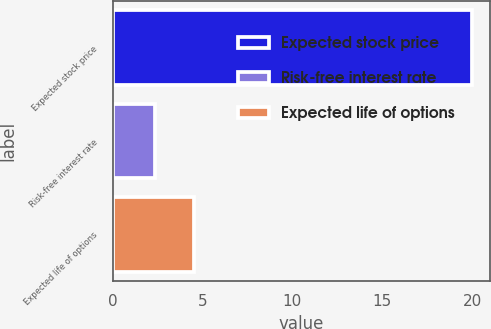Convert chart. <chart><loc_0><loc_0><loc_500><loc_500><bar_chart><fcel>Expected stock price<fcel>Risk-free interest rate<fcel>Expected life of options<nl><fcel>20<fcel>2.37<fcel>4.5<nl></chart> 